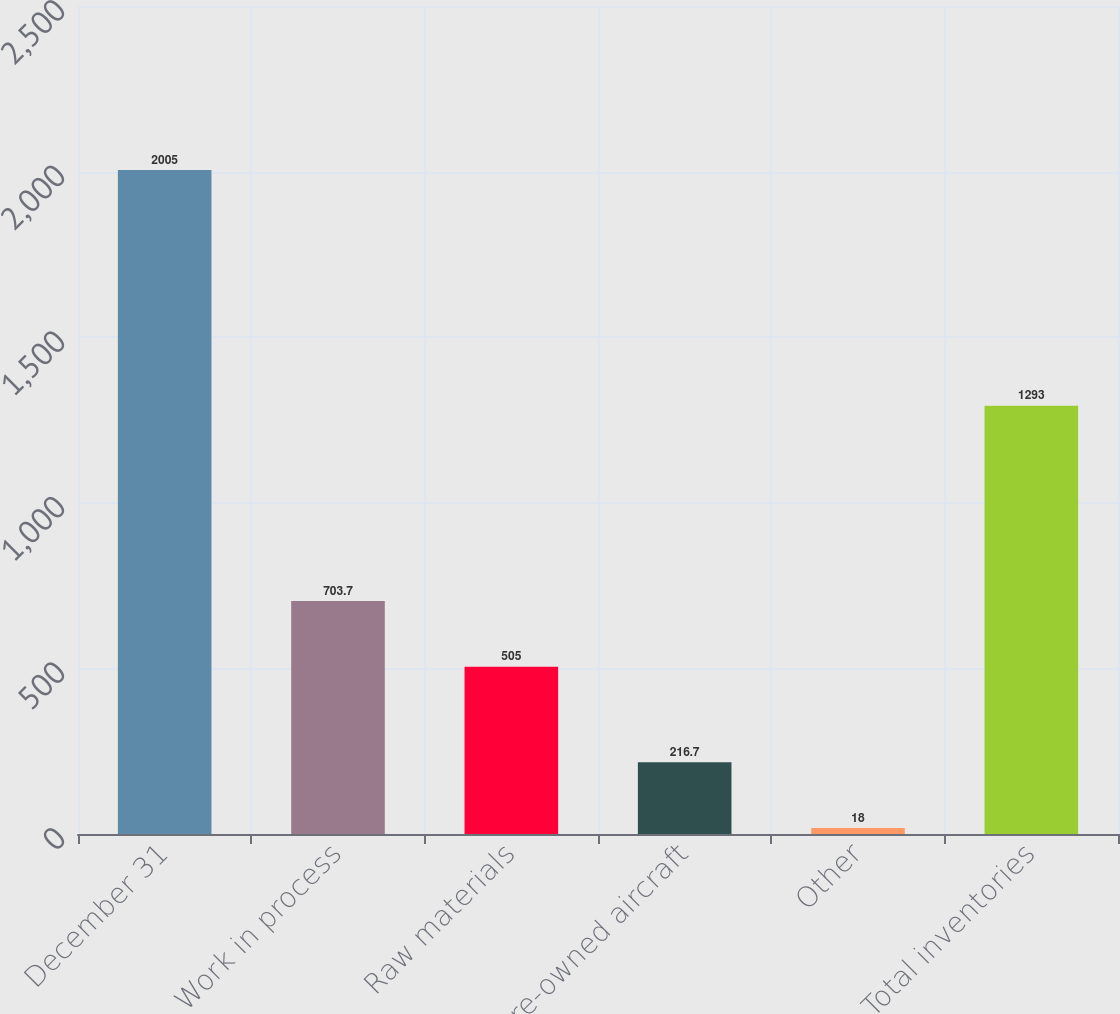Convert chart. <chart><loc_0><loc_0><loc_500><loc_500><bar_chart><fcel>December 31<fcel>Work in process<fcel>Raw materials<fcel>Pre-owned aircraft<fcel>Other<fcel>Total inventories<nl><fcel>2005<fcel>703.7<fcel>505<fcel>216.7<fcel>18<fcel>1293<nl></chart> 